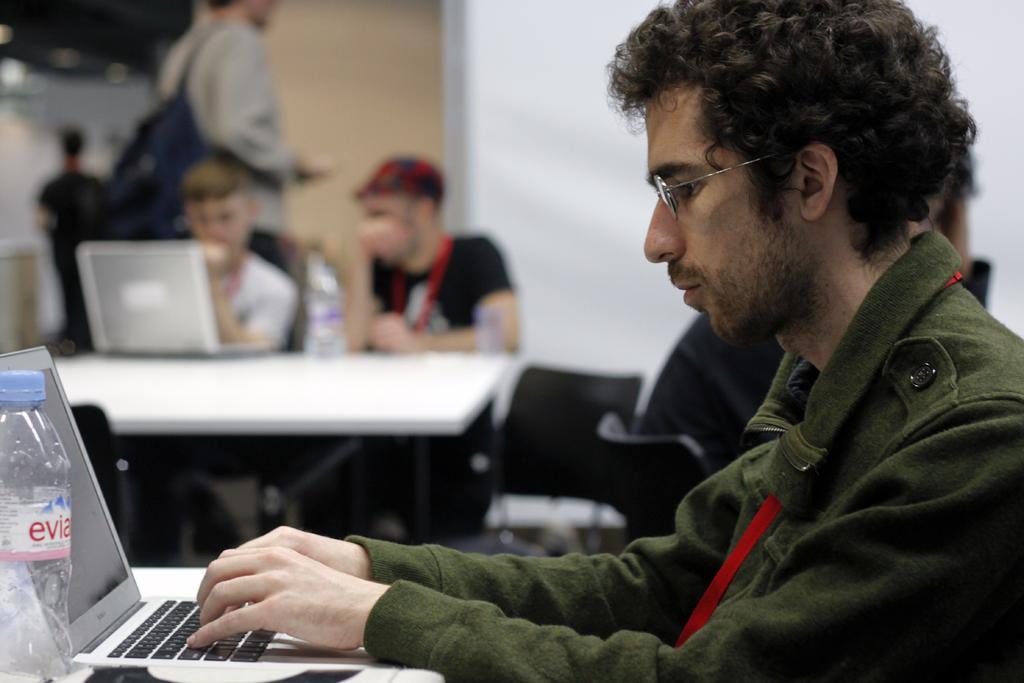Can you describe this image briefly? This image consists of a man wearing green jacket is using laptop. In front of him, there is a table. In the background, there are many people sitting. To the right, there is a wall. 